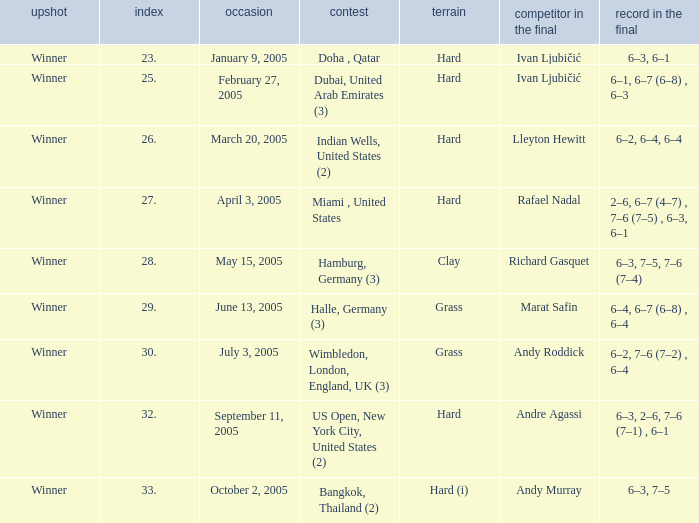Marat Safin is the opponent in the final in what championship? Halle, Germany (3). 